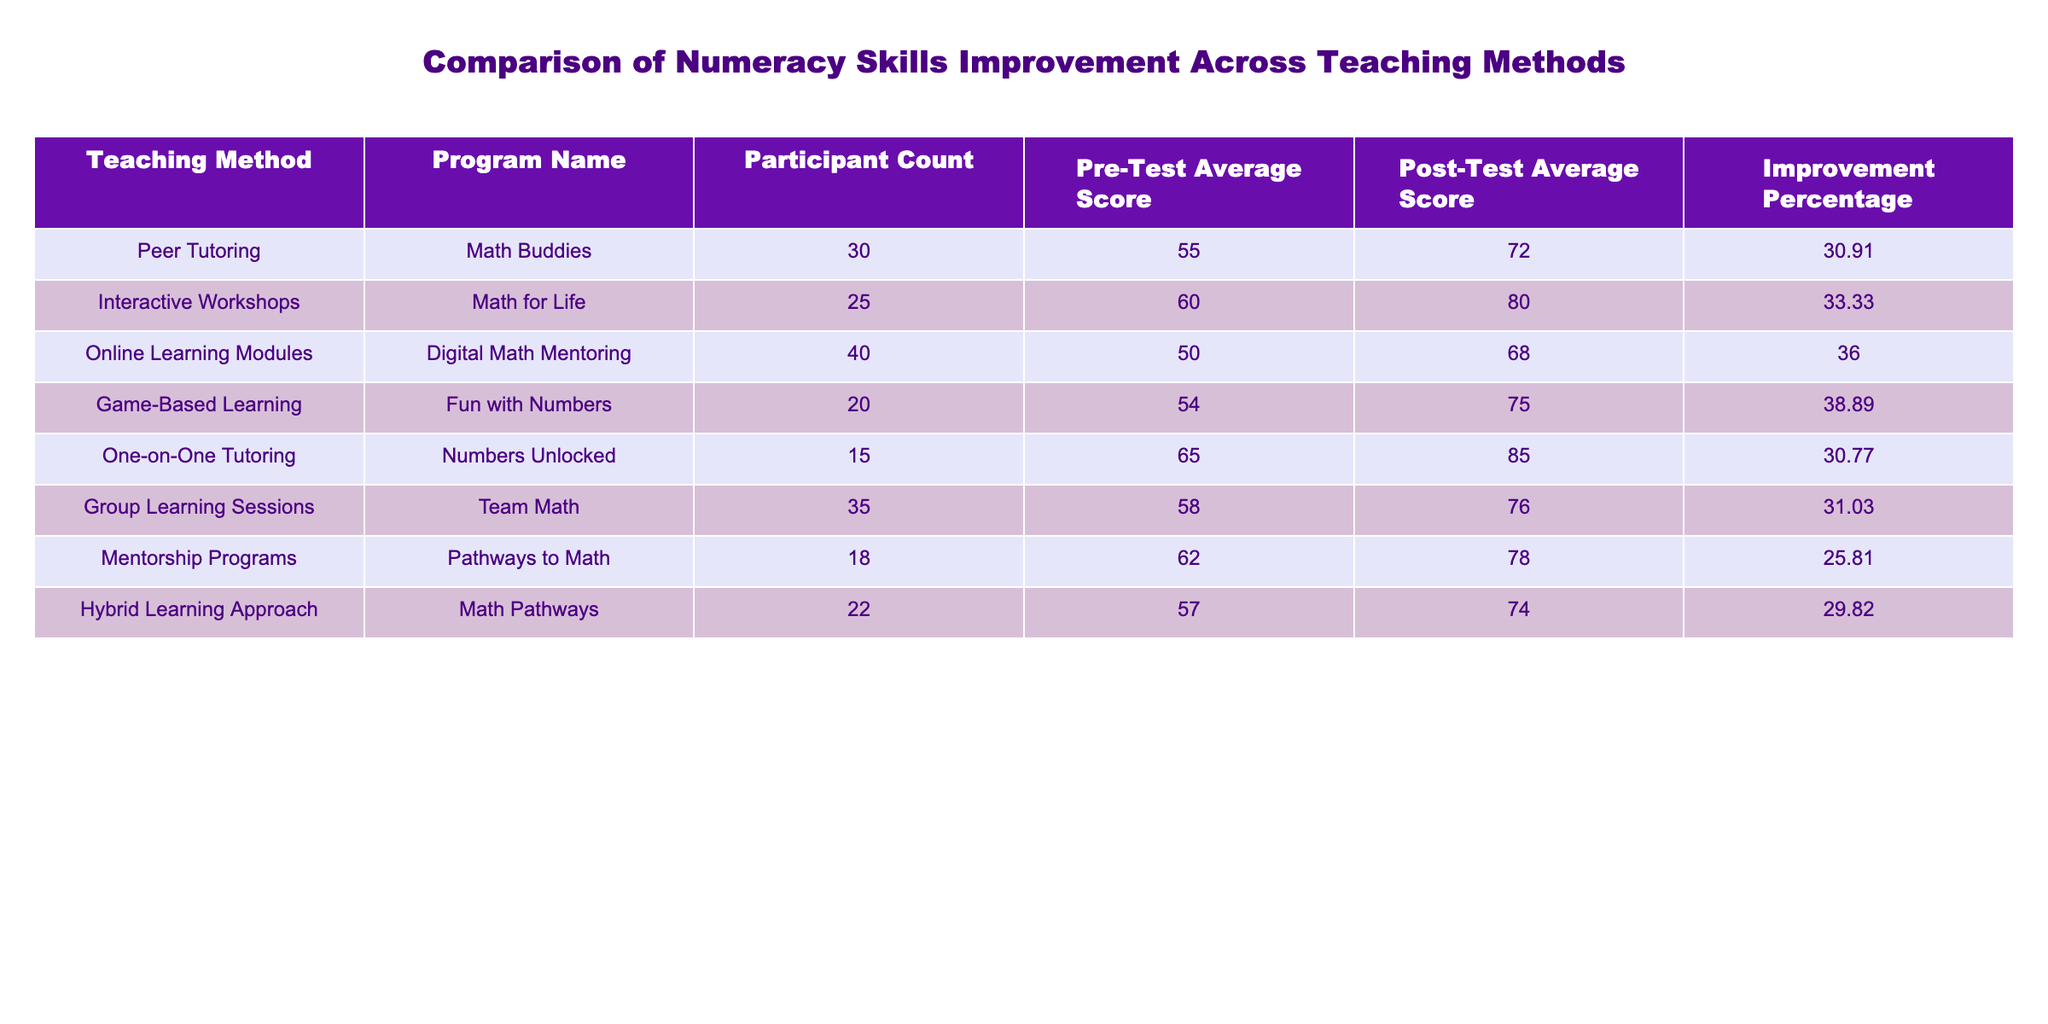What is the highest improvement percentage among the teaching methods? The improvement percentages for each teaching method are listed: Peer Tutoring (30.91), Interactive Workshops (33.33), Online Learning Modules (36.00), Game-Based Learning (38.89), One-on-One Tutoring (30.77), Group Learning Sessions (31.03), Mentorship Programs (25.81), Hybrid Learning Approach (29.82). The highest value is 38.89 from Game-Based Learning.
Answer: 38.89 Which teaching method had the lowest participant count? Looking at the Participant Count column, the methods listed are: Math Buddies (30), Math for Life (25), Digital Math Mentoring (40), Fun with Numbers (20), Numbers Unlocked (15), Team Math (35), Pathways to Math (18), and Math Pathways (22). The lowest count is 15 from Numbers Unlocked.
Answer: 15 What is the average pre-test score across all teaching methods? The pre-test average scores are: 55, 60, 50, 54, 65, 58, 62, and 57. Adding these scores gives a total of  55 + 60 + 50 + 54 + 65 + 58 + 62 + 57 =  421. There are 8 teaching methods, so the average is 421/8 = 52.625.
Answer: 52.625 Is the improvement percentage higher for Online Learning Modules than for Peer Tutoring? The improvement percentage for Online Learning Modules is 36.00 and for Peer Tutoring is 30.91. Since 36.00 is greater than 30.91, the statement is true.
Answer: Yes What is the difference between the highest and lowest post-test scores? The post-test average scores are: 72, 80, 68, 75, 85, 76, 78, and 74. The highest score is 85 (One-on-One Tutoring) and the lowest is 68 (Online Learning Modules). The difference is 85 - 68 = 17.
Answer: 17 Which teaching method had the best improvement percentage and what was the percentage? The best improvement percentage, identified earlier, is from Game-Based Learning with 38.89 percent improvement.
Answer: Game-Based Learning, 38.89 How many teaching methods improved their scores by more than 30%? The improvement percentages above 30% are from Interactive Workshops (33.33), Online Learning Modules (36.00), Game-Based Learning (38.89), and Group Learning Sessions (31.03). Counting these, there are four methods.
Answer: 4 What is the average post-test score across all the methods? The post-test scores are: 72, 80, 68, 75, 85, 76, 78, and 74. Adding these gives a total of 72 + 80 + 68 + 75 + 85 + 76 + 78 + 74 =  618. There are 8 methods, so the average is 618/8 = 77.25.
Answer: 77.25 